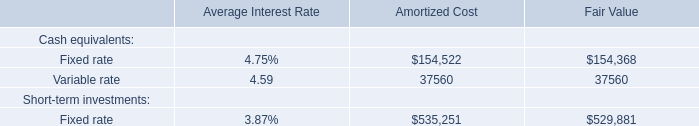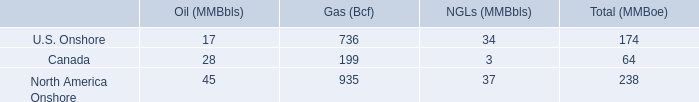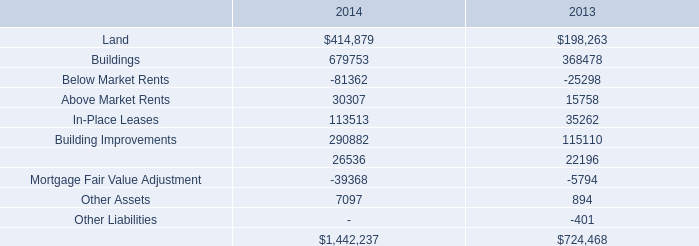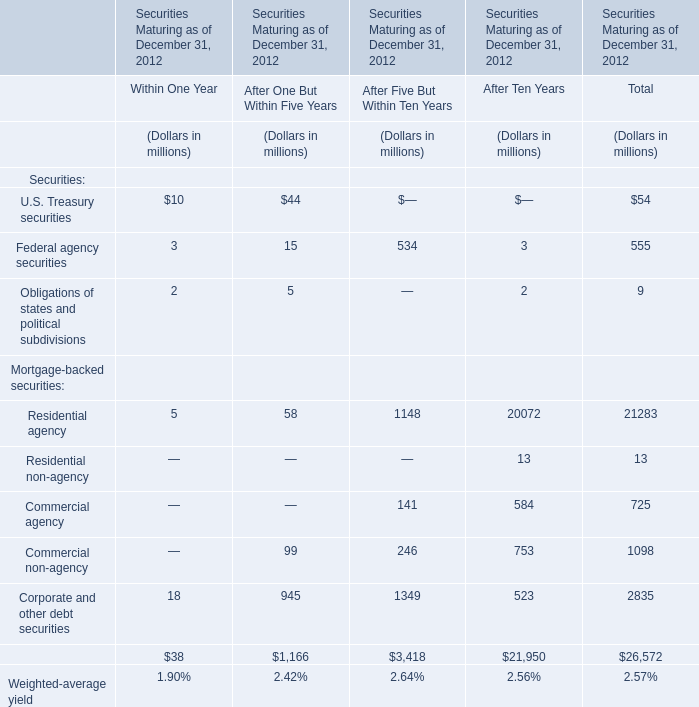In the section with largest amount of Residential agency, what's the sum of Mortgage-backed securities? (in million) 
Computations: ((((20072 + 13) + 584) + 753) + 523)
Answer: 21945.0. 